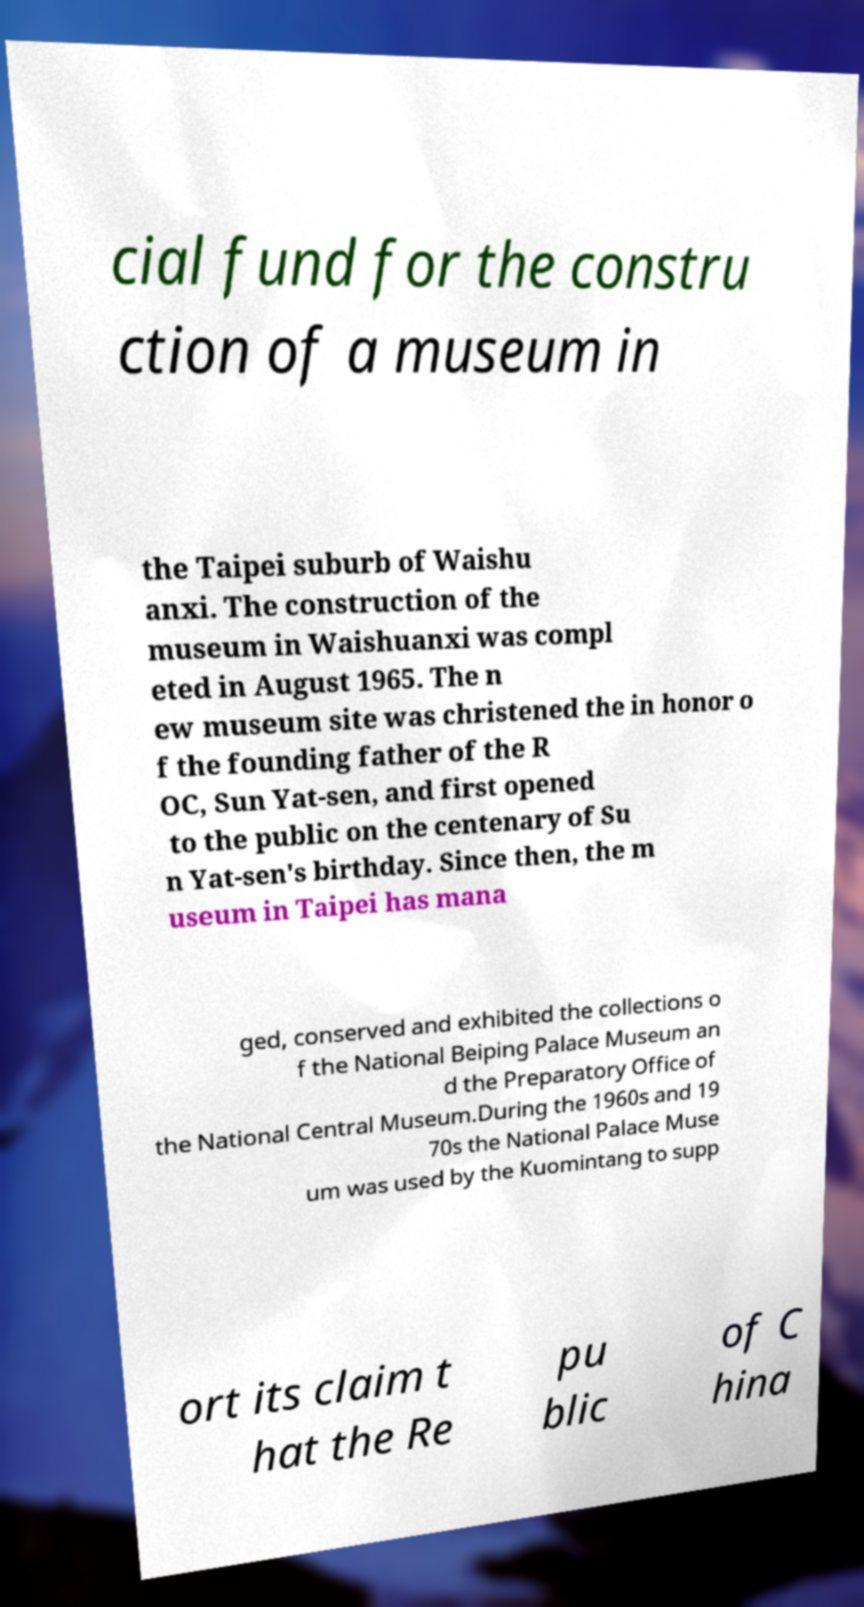Can you accurately transcribe the text from the provided image for me? cial fund for the constru ction of a museum in the Taipei suburb of Waishu anxi. The construction of the museum in Waishuanxi was compl eted in August 1965. The n ew museum site was christened the in honor o f the founding father of the R OC, Sun Yat-sen, and first opened to the public on the centenary of Su n Yat-sen's birthday. Since then, the m useum in Taipei has mana ged, conserved and exhibited the collections o f the National Beiping Palace Museum an d the Preparatory Office of the National Central Museum.During the 1960s and 19 70s the National Palace Muse um was used by the Kuomintang to supp ort its claim t hat the Re pu blic of C hina 